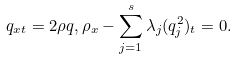<formula> <loc_0><loc_0><loc_500><loc_500>q _ { x t } = 2 \rho q , \rho _ { x } - \sum _ { j = 1 } ^ { s } \lambda _ { j } ( q _ { j } ^ { 2 } ) _ { t } = 0 .</formula> 